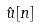Convert formula to latex. <formula><loc_0><loc_0><loc_500><loc_500>\hat { u } [ n ]</formula> 